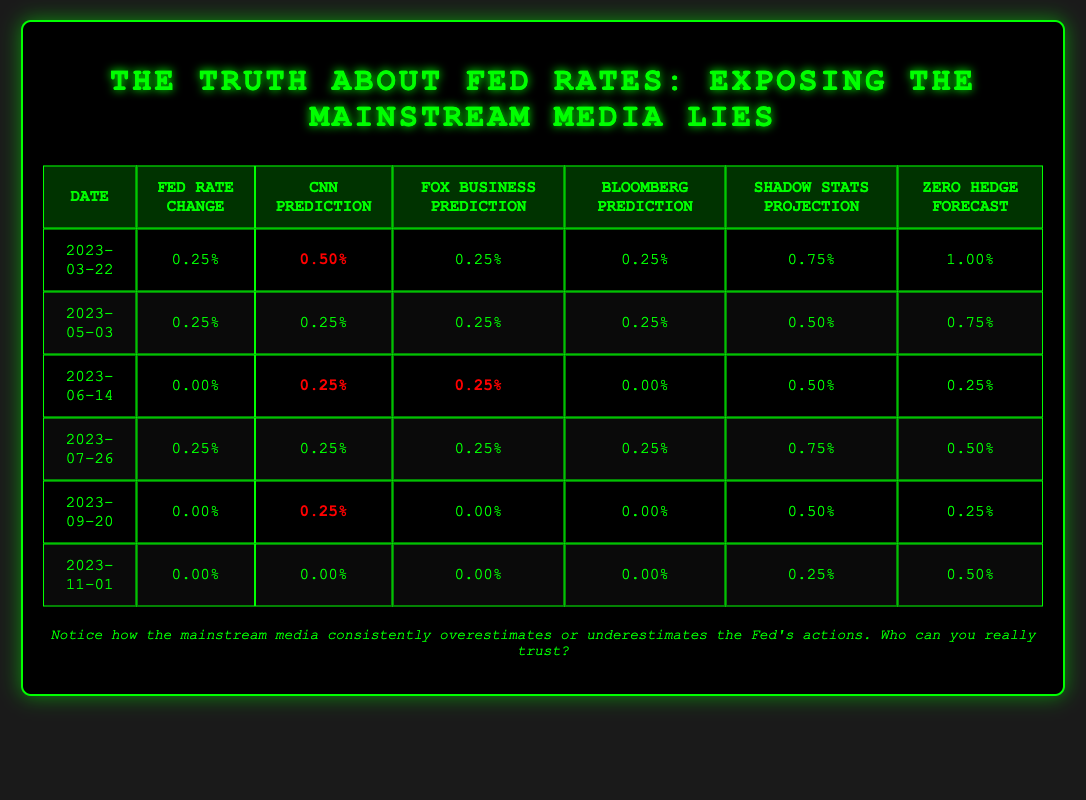What was the Federal Reserve rate change on March 22, 2023? The table shows that on March 22, 2023, the Federal Reserve rate change was 0.25%.
Answer: 0.25% According to the table, which prediction by CNN was the highest in March 2023? The CNN prediction for March 22, 2023, was 0.50%, which is higher than the predictions made by other sources on that date.
Answer: 0.50% What is the average Fed rate change across all dates provided in the table? The Fed rate changes are 0.25, 0.25, 0.00, 0.25, 0.00, and 0.00, summing to 0.75. Dividing this by 6 gives an average of 0.125%.
Answer: 0.125% Did Bloomberg ever predict a rate change different from the actual Fed rate change? Yes, Bloomberg had a different prediction on March 22, predicting 0.25% whereas the actual Fed rate change was 0.25%, and on June 14, the prediction was 0.00%, matching the Fed rate change.
Answer: Yes What was the difference between the highest and lowest predictions from Shadow Stats across the given dates? The highest Shadow Stats projection was 0.75% on March 22, while the lowest was 0.25% on November 1. The difference is 0.75% - 0.25% = 0.50%.
Answer: 0.50% How many times did the Fed change the rate to 0.00%? The Fed changed the rate to 0.00% on June 14, September 20, and November 1, totaling three occurrences.
Answer: 3 What was Zero Hedge’s forecast on July 26, 2023, compared to the actual Fed rate change? On July 26, 2023, Zero Hedge forecasted a 0.50% change, while the actual Fed rate change was 0.25%. The forecast was higher than the actual change.
Answer: Higher Was there any prediction that matched the Fed rate change on September 20, 2023? Yes, on September 20, 2023, both Bloomberg and Fox Business predicted a rate change of 0.00%, which matched the actual Fed rate change.
Answer: Yes What was the total of all predicted values from CNN over the six dates? The CNN predictions are 0.50, 0.25, 0.25, 0.25, 0.25, and 0.00. Summing these gives 1.50%.
Answer: 1.50% What can be inferred about the reliability of mainstream media forecasts based on this table? The table shows that mainstream media predictions often differ from actual Fed changes, indicating possible overestimations or underestimations, raising doubts about their reliability.
Answer: Mainstream media forecasts may lack reliability 